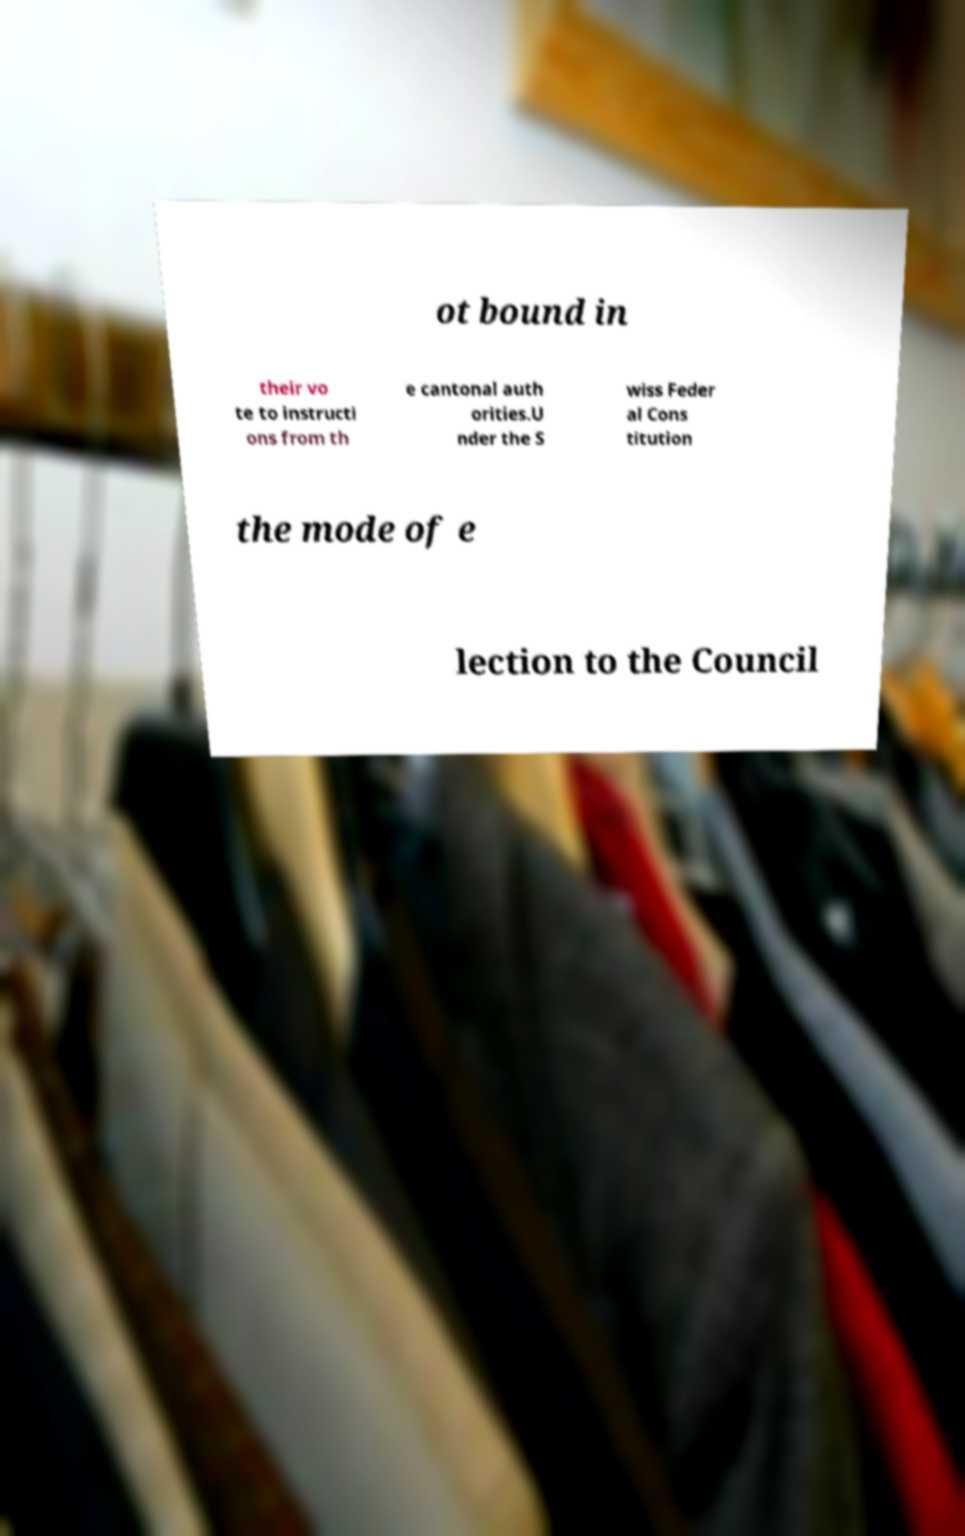For documentation purposes, I need the text within this image transcribed. Could you provide that? ot bound in their vo te to instructi ons from th e cantonal auth orities.U nder the S wiss Feder al Cons titution the mode of e lection to the Council 